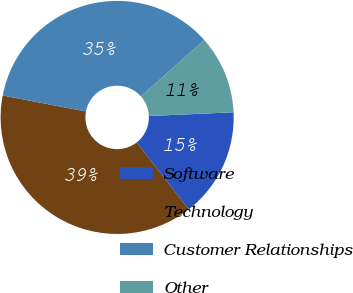Convert chart to OTSL. <chart><loc_0><loc_0><loc_500><loc_500><pie_chart><fcel>Software<fcel>Technology<fcel>Customer Relationships<fcel>Other<nl><fcel>15.17%<fcel>38.54%<fcel>35.44%<fcel>10.85%<nl></chart> 